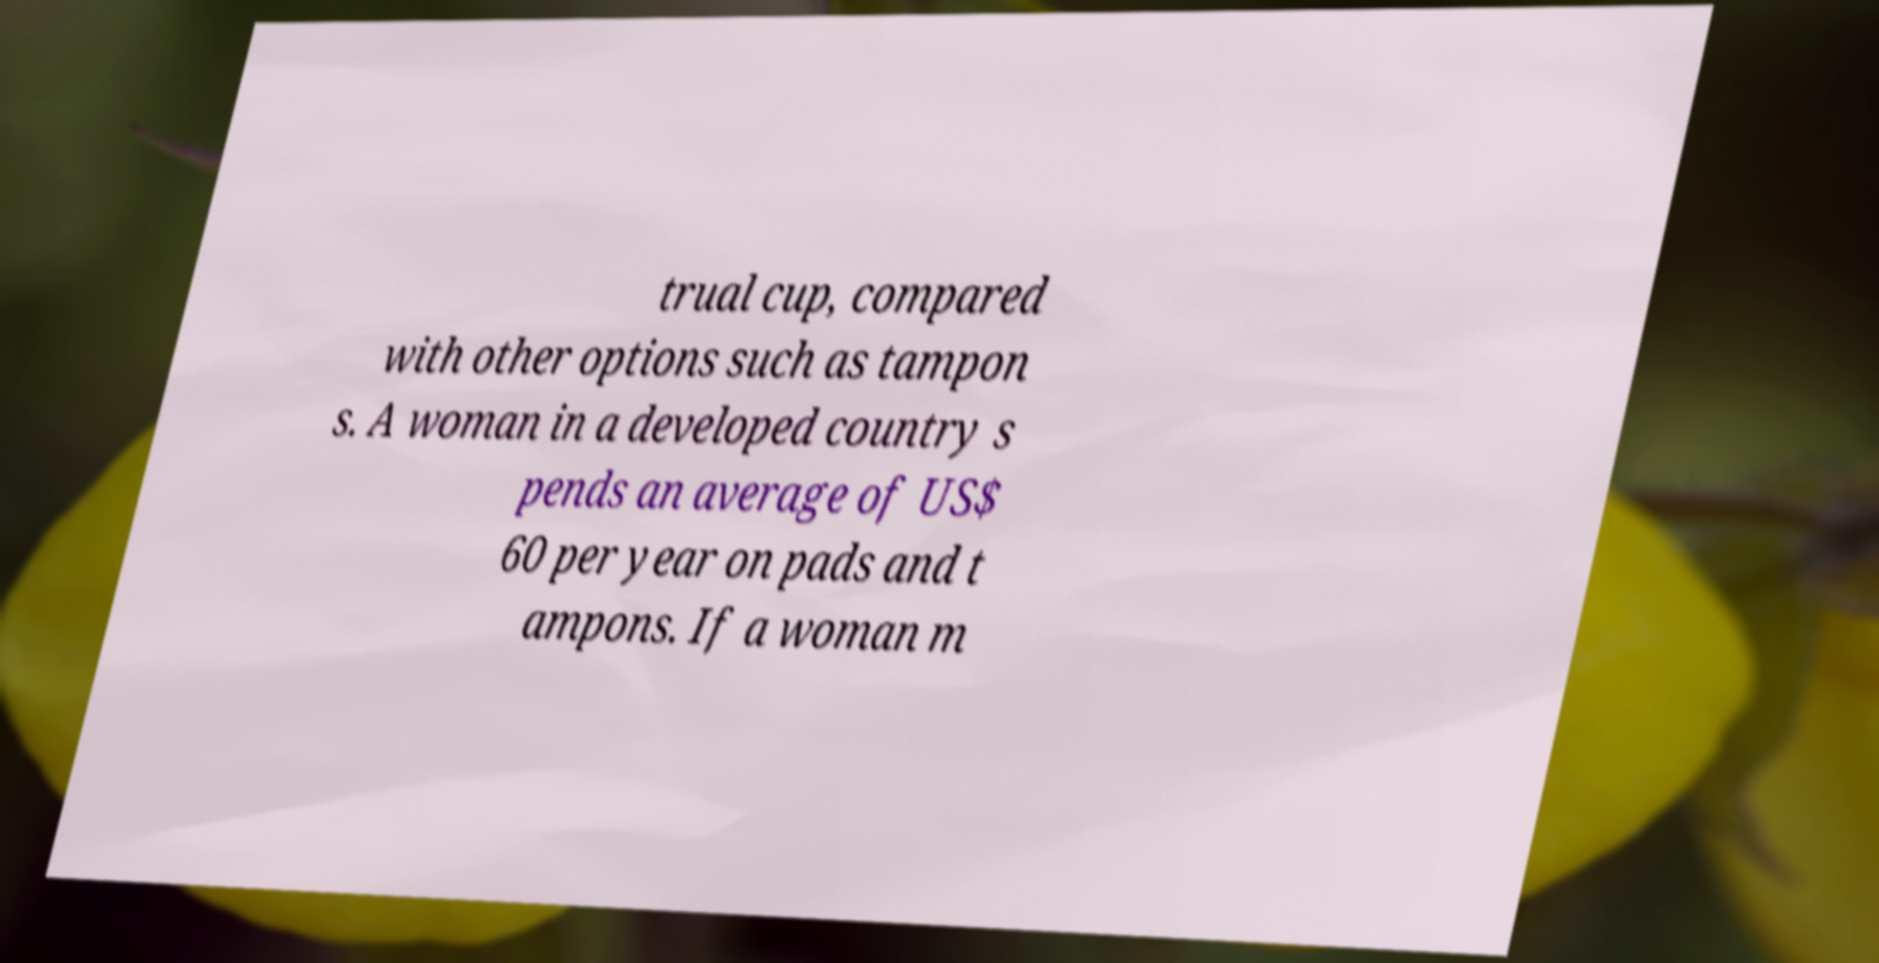For documentation purposes, I need the text within this image transcribed. Could you provide that? trual cup, compared with other options such as tampon s. A woman in a developed country s pends an average of US$ 60 per year on pads and t ampons. If a woman m 